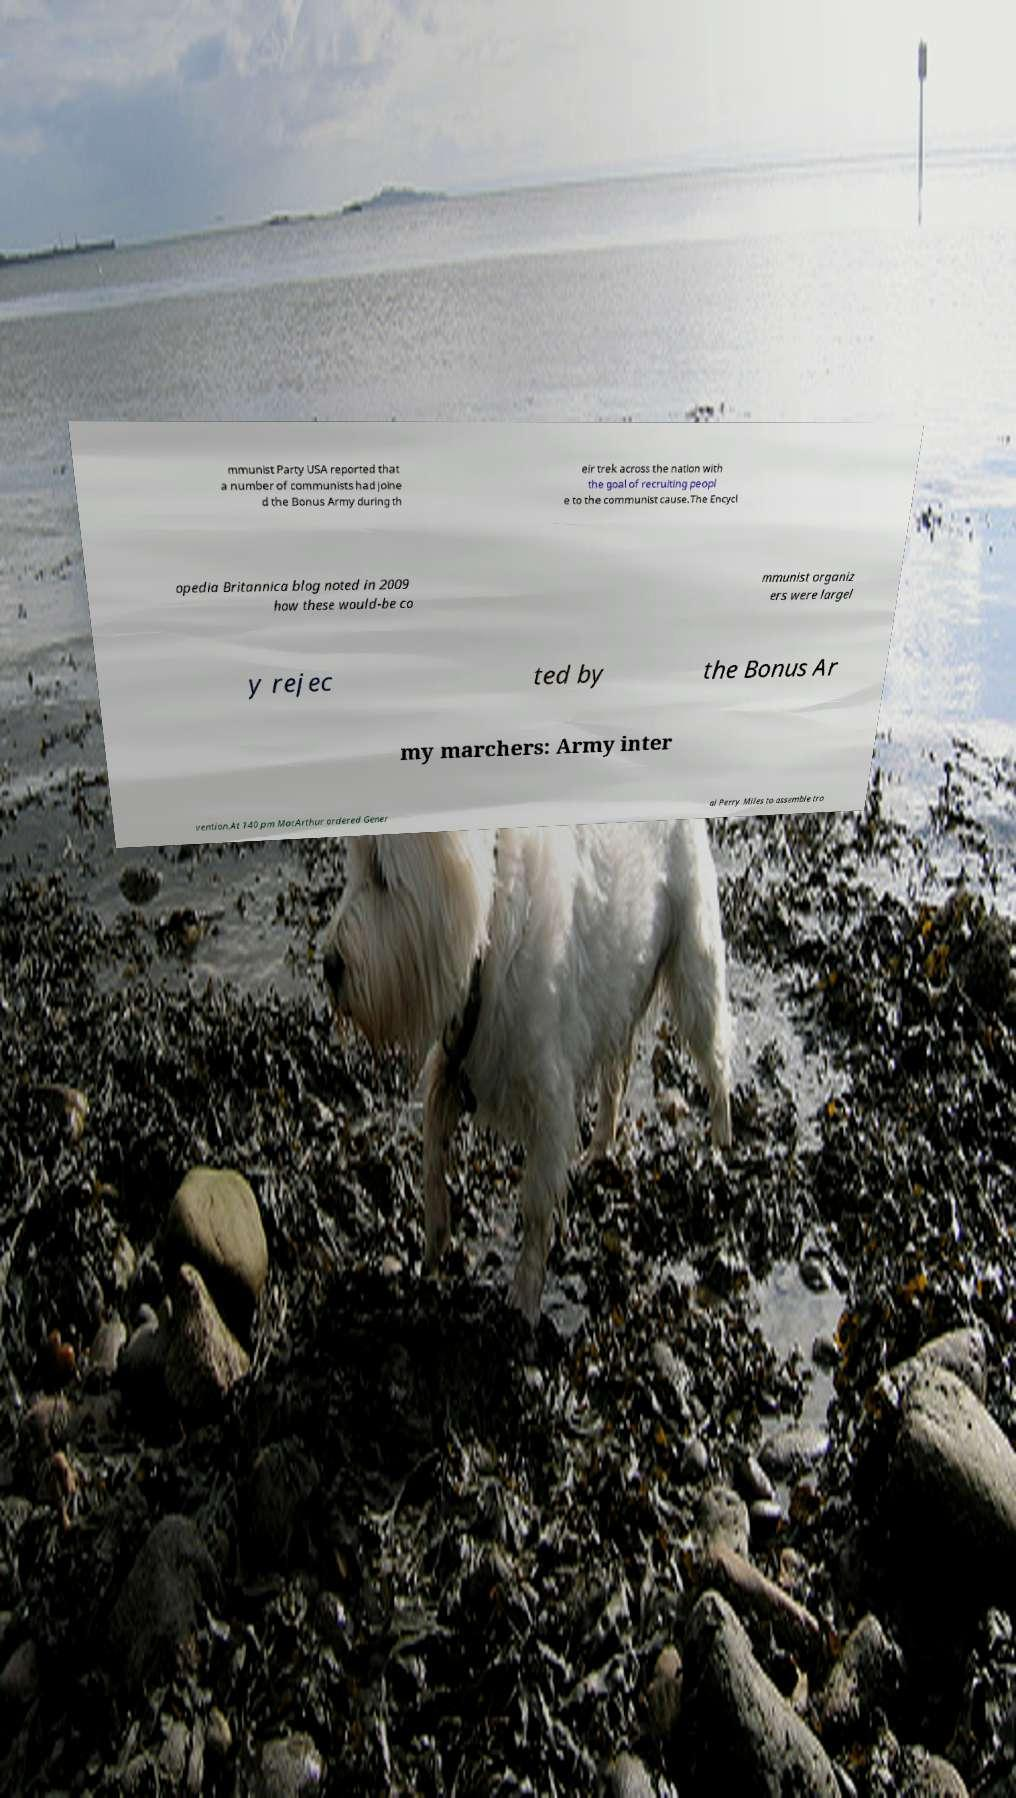For documentation purposes, I need the text within this image transcribed. Could you provide that? mmunist Party USA reported that a number of communists had joine d the Bonus Army during th eir trek across the nation with the goal of recruiting peopl e to the communist cause.The Encycl opedia Britannica blog noted in 2009 how these would-be co mmunist organiz ers were largel y rejec ted by the Bonus Ar my marchers: Army inter vention.At 140 pm MacArthur ordered Gener al Perry Miles to assemble tro 